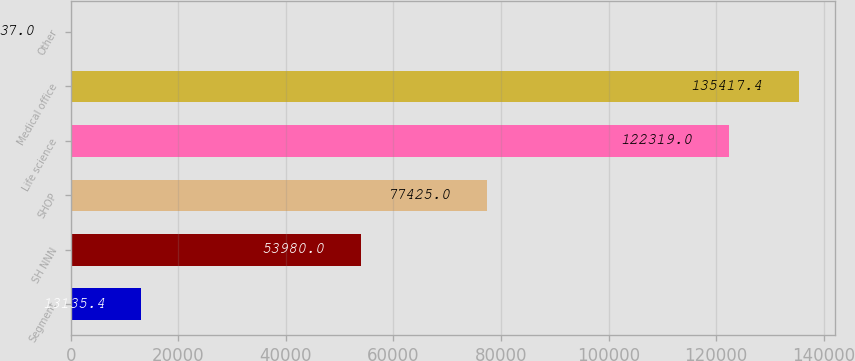Convert chart. <chart><loc_0><loc_0><loc_500><loc_500><bar_chart><fcel>Segment<fcel>SH NNN<fcel>SHOP<fcel>Life science<fcel>Medical office<fcel>Other<nl><fcel>13135.4<fcel>53980<fcel>77425<fcel>122319<fcel>135417<fcel>37<nl></chart> 